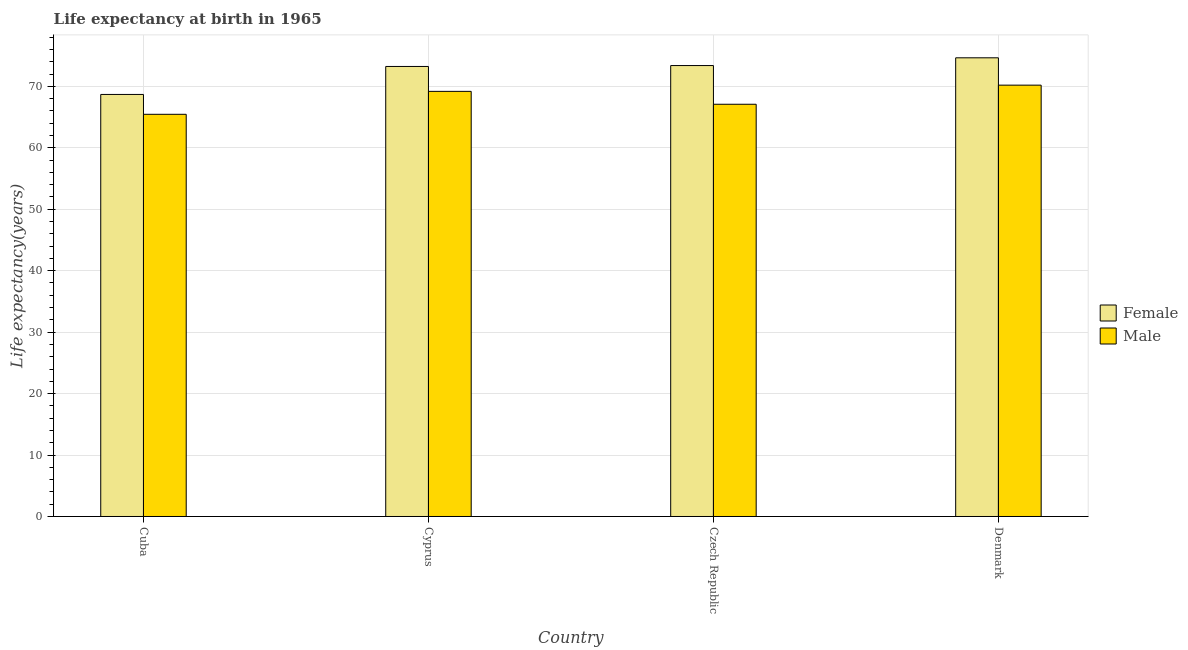How many groups of bars are there?
Your response must be concise. 4. Are the number of bars per tick equal to the number of legend labels?
Keep it short and to the point. Yes. Are the number of bars on each tick of the X-axis equal?
Offer a terse response. Yes. How many bars are there on the 4th tick from the left?
Your answer should be compact. 2. What is the label of the 3rd group of bars from the left?
Give a very brief answer. Czech Republic. What is the life expectancy(female) in Cuba?
Ensure brevity in your answer.  68.69. Across all countries, what is the maximum life expectancy(male)?
Offer a terse response. 70.2. Across all countries, what is the minimum life expectancy(female)?
Your answer should be compact. 68.69. In which country was the life expectancy(female) maximum?
Provide a succinct answer. Denmark. In which country was the life expectancy(male) minimum?
Offer a very short reply. Cuba. What is the total life expectancy(female) in the graph?
Keep it short and to the point. 289.97. What is the difference between the life expectancy(male) in Cuba and that in Czech Republic?
Offer a very short reply. -1.64. What is the difference between the life expectancy(male) in Cuba and the life expectancy(female) in Czech Republic?
Your response must be concise. -7.94. What is the average life expectancy(female) per country?
Your answer should be very brief. 72.49. What is the difference between the life expectancy(male) and life expectancy(female) in Denmark?
Give a very brief answer. -4.45. What is the ratio of the life expectancy(female) in Cuba to that in Cyprus?
Your answer should be compact. 0.94. Is the life expectancy(male) in Cyprus less than that in Denmark?
Provide a short and direct response. Yes. Is the difference between the life expectancy(male) in Cuba and Czech Republic greater than the difference between the life expectancy(female) in Cuba and Czech Republic?
Make the answer very short. Yes. What is the difference between the highest and the second highest life expectancy(male)?
Make the answer very short. 1.01. What is the difference between the highest and the lowest life expectancy(female)?
Your response must be concise. 5.96. In how many countries, is the life expectancy(female) greater than the average life expectancy(female) taken over all countries?
Ensure brevity in your answer.  3. Is the sum of the life expectancy(male) in Cyprus and Czech Republic greater than the maximum life expectancy(female) across all countries?
Offer a terse response. Yes. What does the 1st bar from the right in Cyprus represents?
Keep it short and to the point. Male. What is the difference between two consecutive major ticks on the Y-axis?
Keep it short and to the point. 10. Does the graph contain any zero values?
Your answer should be compact. No. How many legend labels are there?
Ensure brevity in your answer.  2. What is the title of the graph?
Make the answer very short. Life expectancy at birth in 1965. Does "Nitrous oxide emissions" appear as one of the legend labels in the graph?
Your answer should be compact. No. What is the label or title of the Y-axis?
Give a very brief answer. Life expectancy(years). What is the Life expectancy(years) of Female in Cuba?
Provide a succinct answer. 68.69. What is the Life expectancy(years) of Male in Cuba?
Keep it short and to the point. 65.45. What is the Life expectancy(years) of Female in Cyprus?
Offer a very short reply. 73.24. What is the Life expectancy(years) in Male in Cyprus?
Make the answer very short. 69.19. What is the Life expectancy(years) in Female in Czech Republic?
Offer a terse response. 73.39. What is the Life expectancy(years) of Male in Czech Republic?
Your answer should be very brief. 67.09. What is the Life expectancy(years) in Female in Denmark?
Keep it short and to the point. 74.65. What is the Life expectancy(years) of Male in Denmark?
Keep it short and to the point. 70.2. Across all countries, what is the maximum Life expectancy(years) of Female?
Make the answer very short. 74.65. Across all countries, what is the maximum Life expectancy(years) in Male?
Provide a short and direct response. 70.2. Across all countries, what is the minimum Life expectancy(years) of Female?
Ensure brevity in your answer.  68.69. Across all countries, what is the minimum Life expectancy(years) of Male?
Keep it short and to the point. 65.45. What is the total Life expectancy(years) of Female in the graph?
Provide a short and direct response. 289.97. What is the total Life expectancy(years) in Male in the graph?
Keep it short and to the point. 271.93. What is the difference between the Life expectancy(years) in Female in Cuba and that in Cyprus?
Make the answer very short. -4.55. What is the difference between the Life expectancy(years) in Male in Cuba and that in Cyprus?
Provide a succinct answer. -3.73. What is the difference between the Life expectancy(years) in Female in Cuba and that in Czech Republic?
Give a very brief answer. -4.7. What is the difference between the Life expectancy(years) of Male in Cuba and that in Czech Republic?
Your response must be concise. -1.64. What is the difference between the Life expectancy(years) in Female in Cuba and that in Denmark?
Make the answer very short. -5.96. What is the difference between the Life expectancy(years) of Male in Cuba and that in Denmark?
Make the answer very short. -4.75. What is the difference between the Life expectancy(years) in Female in Cyprus and that in Czech Republic?
Make the answer very short. -0.15. What is the difference between the Life expectancy(years) in Male in Cyprus and that in Czech Republic?
Offer a very short reply. 2.1. What is the difference between the Life expectancy(years) of Female in Cyprus and that in Denmark?
Offer a terse response. -1.41. What is the difference between the Life expectancy(years) in Male in Cyprus and that in Denmark?
Give a very brief answer. -1.01. What is the difference between the Life expectancy(years) of Female in Czech Republic and that in Denmark?
Provide a succinct answer. -1.26. What is the difference between the Life expectancy(years) of Male in Czech Republic and that in Denmark?
Provide a short and direct response. -3.11. What is the difference between the Life expectancy(years) in Female in Cuba and the Life expectancy(years) in Male in Cyprus?
Your answer should be very brief. -0.5. What is the difference between the Life expectancy(years) of Female in Cuba and the Life expectancy(years) of Male in Czech Republic?
Your response must be concise. 1.6. What is the difference between the Life expectancy(years) of Female in Cuba and the Life expectancy(years) of Male in Denmark?
Your answer should be compact. -1.51. What is the difference between the Life expectancy(years) of Female in Cyprus and the Life expectancy(years) of Male in Czech Republic?
Provide a short and direct response. 6.15. What is the difference between the Life expectancy(years) in Female in Cyprus and the Life expectancy(years) in Male in Denmark?
Your response must be concise. 3.04. What is the difference between the Life expectancy(years) in Female in Czech Republic and the Life expectancy(years) in Male in Denmark?
Give a very brief answer. 3.19. What is the average Life expectancy(years) of Female per country?
Make the answer very short. 72.49. What is the average Life expectancy(years) in Male per country?
Your response must be concise. 67.98. What is the difference between the Life expectancy(years) in Female and Life expectancy(years) in Male in Cuba?
Give a very brief answer. 3.23. What is the difference between the Life expectancy(years) in Female and Life expectancy(years) in Male in Cyprus?
Give a very brief answer. 4.05. What is the difference between the Life expectancy(years) in Female and Life expectancy(years) in Male in Czech Republic?
Ensure brevity in your answer.  6.3. What is the difference between the Life expectancy(years) of Female and Life expectancy(years) of Male in Denmark?
Give a very brief answer. 4.45. What is the ratio of the Life expectancy(years) of Female in Cuba to that in Cyprus?
Provide a short and direct response. 0.94. What is the ratio of the Life expectancy(years) in Male in Cuba to that in Cyprus?
Ensure brevity in your answer.  0.95. What is the ratio of the Life expectancy(years) of Female in Cuba to that in Czech Republic?
Offer a terse response. 0.94. What is the ratio of the Life expectancy(years) in Male in Cuba to that in Czech Republic?
Provide a short and direct response. 0.98. What is the ratio of the Life expectancy(years) in Female in Cuba to that in Denmark?
Make the answer very short. 0.92. What is the ratio of the Life expectancy(years) of Male in Cuba to that in Denmark?
Offer a very short reply. 0.93. What is the ratio of the Life expectancy(years) of Male in Cyprus to that in Czech Republic?
Your response must be concise. 1.03. What is the ratio of the Life expectancy(years) of Female in Cyprus to that in Denmark?
Your answer should be very brief. 0.98. What is the ratio of the Life expectancy(years) in Male in Cyprus to that in Denmark?
Keep it short and to the point. 0.99. What is the ratio of the Life expectancy(years) of Female in Czech Republic to that in Denmark?
Offer a very short reply. 0.98. What is the ratio of the Life expectancy(years) in Male in Czech Republic to that in Denmark?
Offer a terse response. 0.96. What is the difference between the highest and the second highest Life expectancy(years) of Female?
Ensure brevity in your answer.  1.26. What is the difference between the highest and the lowest Life expectancy(years) in Female?
Your answer should be compact. 5.96. What is the difference between the highest and the lowest Life expectancy(years) in Male?
Provide a short and direct response. 4.75. 